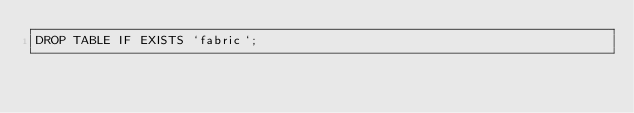<code> <loc_0><loc_0><loc_500><loc_500><_SQL_>DROP TABLE IF EXISTS `fabric`;</code> 